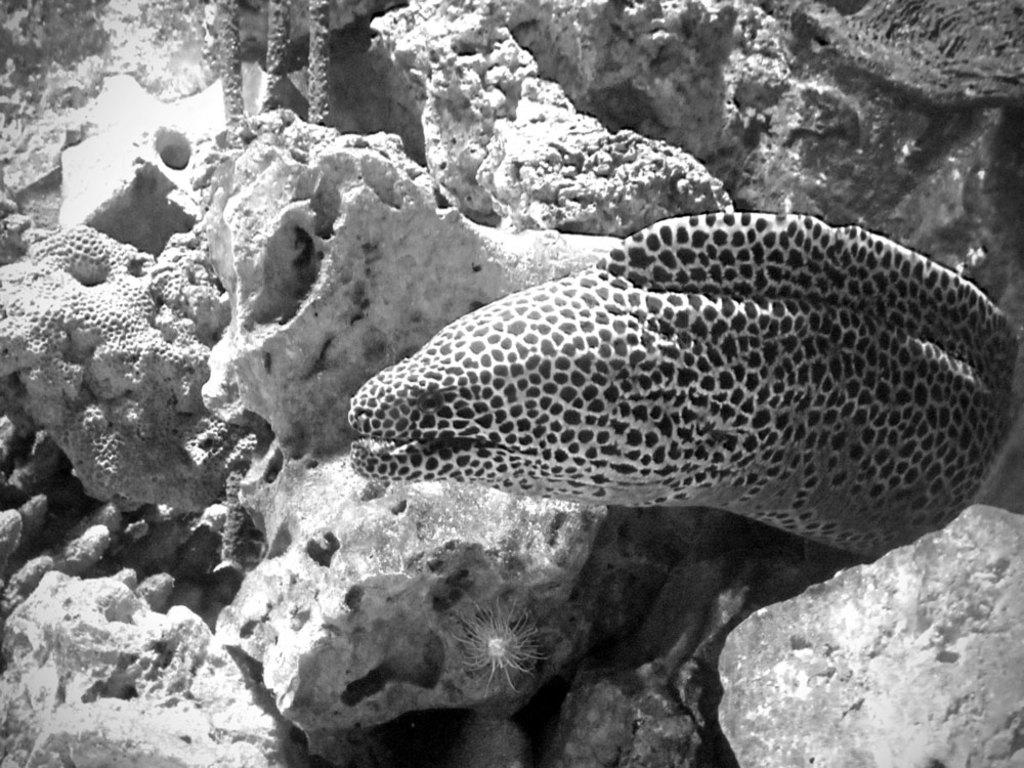What is the color scheme of the image? The image is in black and white. What type of animal can be seen in the image? There is an aquatic animal in the image. What can be seen in the background of the image? There are marine plants and coral reefs in the background of the image. Can you tell me how many maids are present in the image? There are no maids present in the image; it features an aquatic animal in a marine environment. What type of fowl can be seen flying in the image? There is no fowl present in the image; it features an aquatic animal in a marine environment. 